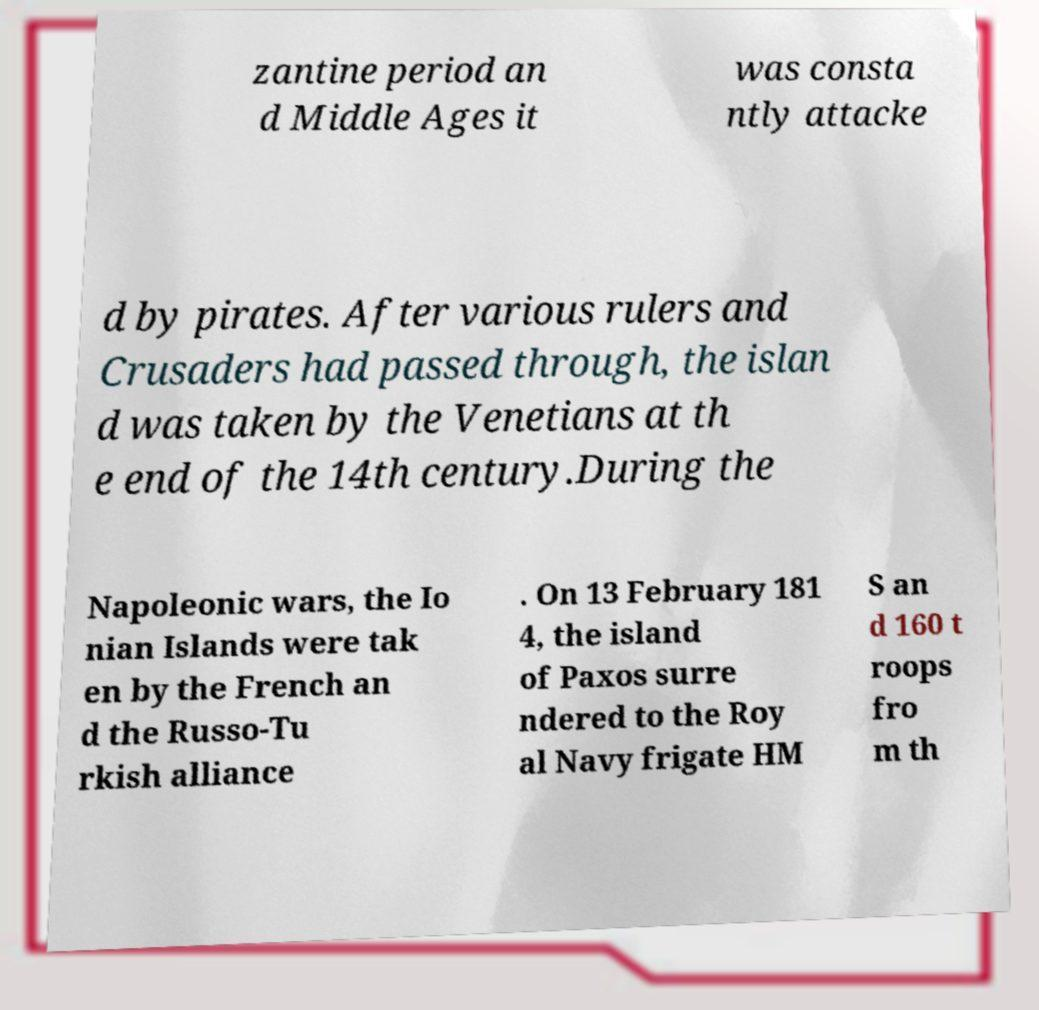Please read and relay the text visible in this image. What does it say? zantine period an d Middle Ages it was consta ntly attacke d by pirates. After various rulers and Crusaders had passed through, the islan d was taken by the Venetians at th e end of the 14th century.During the Napoleonic wars, the Io nian Islands were tak en by the French an d the Russo-Tu rkish alliance . On 13 February 181 4, the island of Paxos surre ndered to the Roy al Navy frigate HM S an d 160 t roops fro m th 